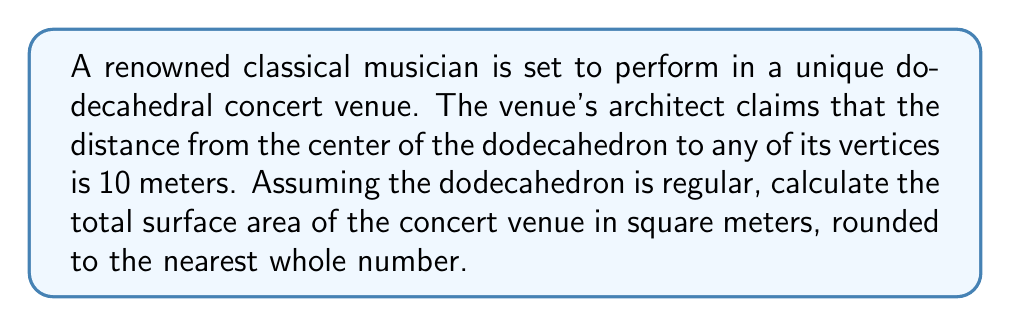Can you answer this question? Let's approach this step-by-step:

1) In a regular dodecahedron, the distance from the center to a vertex is given by the formula:

   $$R = a \sqrt{\frac{3}{4} + \frac{\sqrt{5}}{4}}$$

   where $R$ is the radius (distance from center to vertex) and $a$ is the edge length.

2) We're given that $R = 10$ meters. Let's solve for $a$:

   $$10 = a \sqrt{\frac{3}{4} + \frac{\sqrt{5}}{4}}$$
   $$a = \frac{10}{\sqrt{\frac{3}{4} + \frac{\sqrt{5}}{4}}}$$

3) Simplify the denominator:

   $$a = \frac{10}{\sqrt{\frac{3+\sqrt{5}}{4}}} = \frac{20}{\sqrt{3+\sqrt{5}}}$$

4) The surface area of a regular dodecahedron is given by the formula:

   $$SA = 3a^2\sqrt{25+10\sqrt{5}}$$

5) Substitute our expression for $a$:

   $$SA = 3\left(\frac{20}{\sqrt{3+\sqrt{5}}}\right)^2\sqrt{25+10\sqrt{5}}$$

6) Simplify:

   $$SA = \frac{1200}{3+\sqrt{5}}\sqrt{25+10\sqrt{5}}$$

7) Calculate this value:

   $$SA \approx 471.2044 \text{ square meters}$$

8) Rounding to the nearest whole number:

   $$SA \approx 471 \text{ square meters}$$
Answer: 471 square meters 